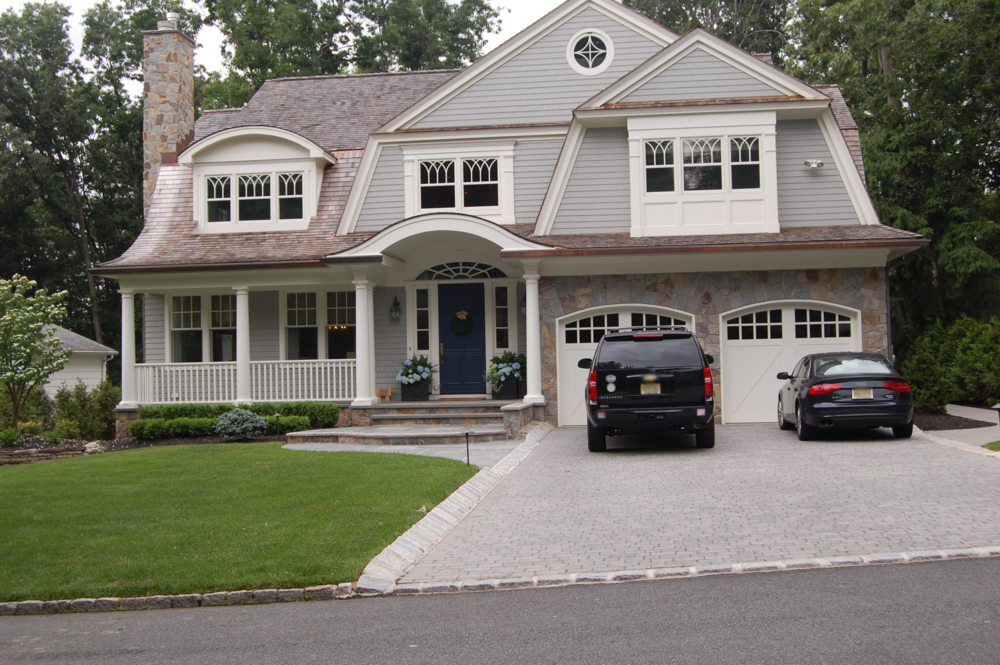If this house were enchanted, what magical features might it possess? This enchanted house could possess a variety of magical features. The front porch might be lined with blooming, talking flowers that welcome guests and keep guard. The blue front door could lead to various rooms depending on who enters, creating a unique experience for each visitor. Inside, the fireplace could not only provide warmth but also act as a portal to other whimsical environments. The windows might offer views into other magical realms, and the house itself could rearrange its layout to fit the needs and desires of its inhabitants. At night, the garden could glow with bioluminescent plants, and the path to the door could guide visitors with self-illuminating stones. The house would feel alive, with each element contributing to its enchanted character. 